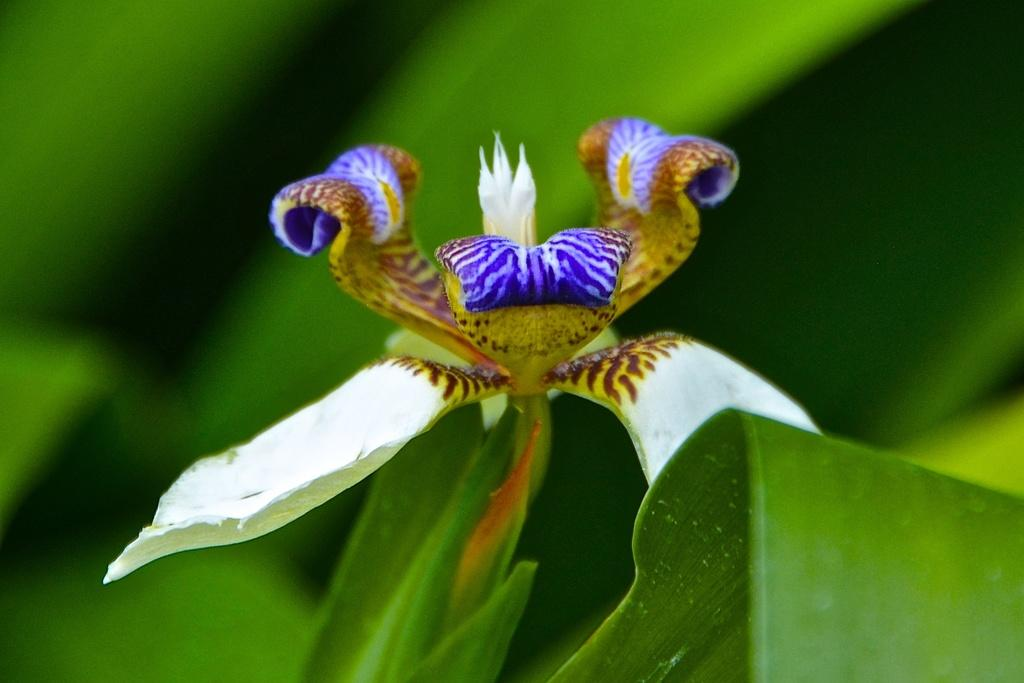What is present in the image? There is a flower in the image. Can you describe the color of the flower? The flower is white and blue in color. What else can be seen in the image besides the flower? There are plants visible in the image. Can you tell me how many feathers are attached to the flower in the image? There are no feathers present on the flower in the image. What type of road can be seen in the image? There is no road present in the image. 